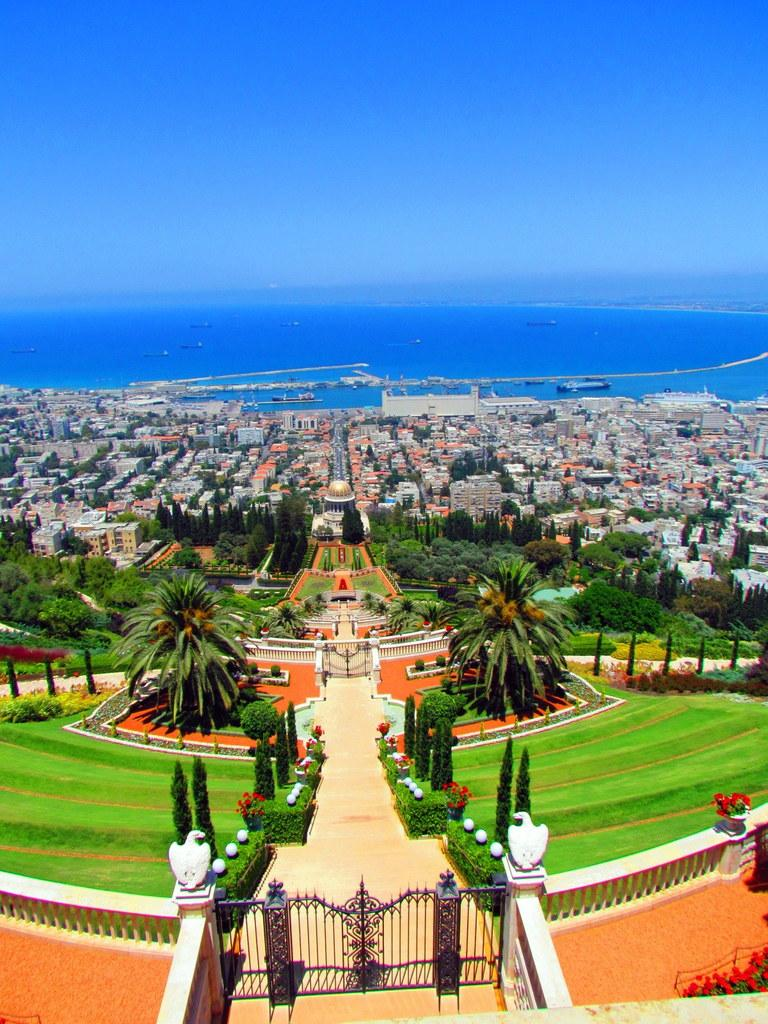What type of structure can be seen in the image? There is a gate in the image. What is located near the gate? There is a fence in the image. What decorative elements are present in the image? There are bird statues on pillars in the image. What type of vegetation is visible in the image? There are plants, flowers, grass, and trees in the image. What can be seen in the background of the image? There are buildings and water visible in the image. What is the color of the sky in the image? The sky is blue in the image. What direction is the gate facing in the image? The provided facts do not specify the direction the gate is facing, so it cannot be determined from the image. What type of knife is being used to cut the grass in the image? There is no knife present in the image, and the grass is not being cut. 